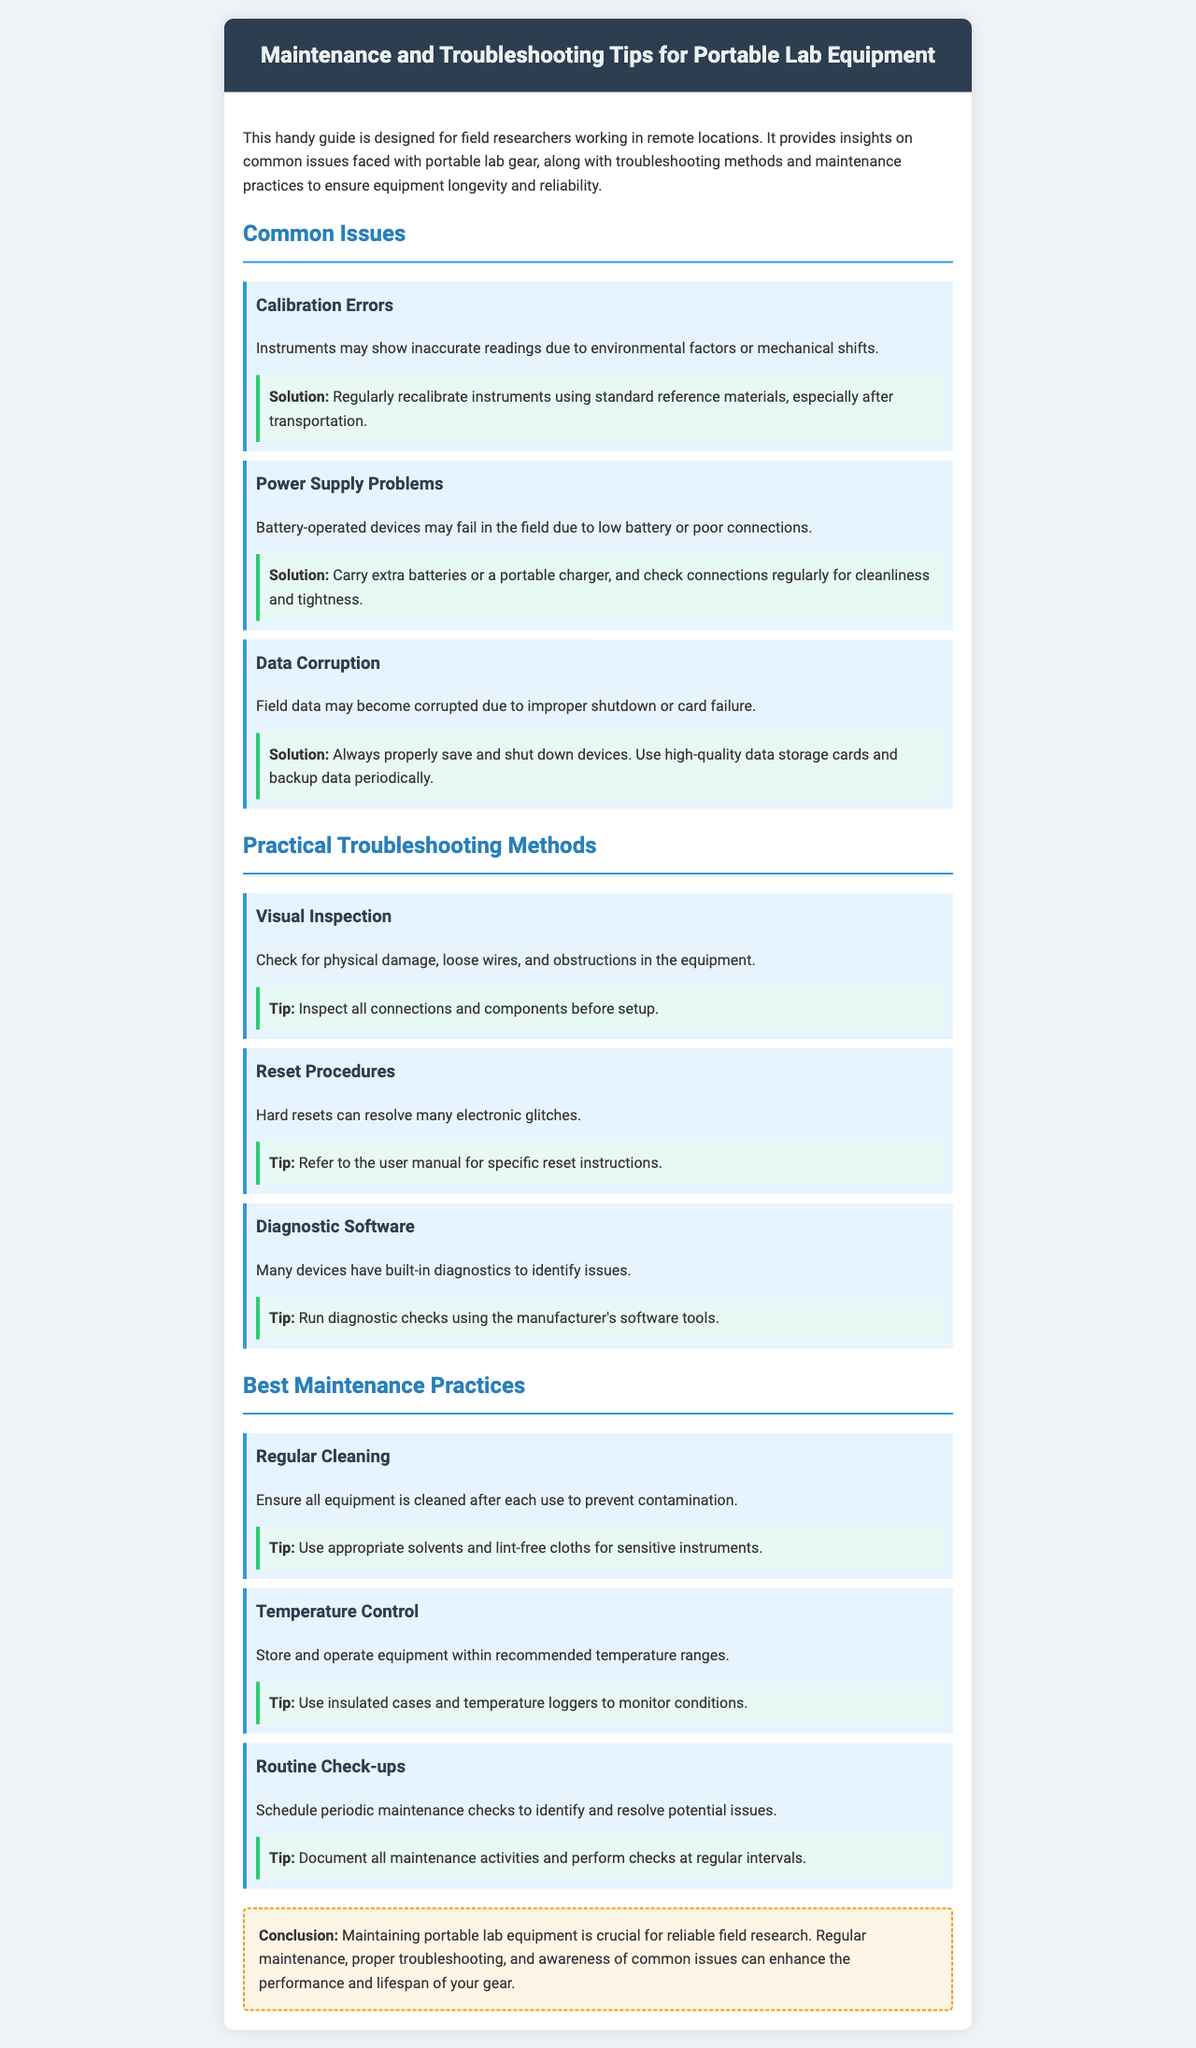What is the primary purpose of the brochure? The primary purpose of the brochure is to provide insights on common issues faced with portable lab gear, along with troubleshooting methods and maintenance practices.
Answer: Provide insights on common issues and troubleshooting methods What issue is related to battery-operated devices? The issue related to battery-operated devices is "Power Supply Problems."
Answer: Power Supply Problems How can you prevent data corruption in the field? You can prevent data corruption by properly saving and shutting down devices and using high-quality data storage cards.
Answer: Properly saving and shutting down devices What is one suggested maintenance practice? One suggested maintenance practice is "Regular Cleaning."
Answer: Regular Cleaning Which method involves using the manufacturer's tools? The method that involves using the manufacturer's tools is "Diagnostic Software."
Answer: Diagnostic Software What type of inspection is recommended before setting up equipment? "Visual Inspection" is recommended before setting up equipment.
Answer: Visual Inspection What strong recommendation is made regarding calibration? The strong recommendation is to "Regularly recalibrate instruments using standard reference materials."
Answer: Regularly recalibrate instruments How often should maintenance checks be scheduled? Maintenance checks should be scheduled periodically.
Answer: Periodically 